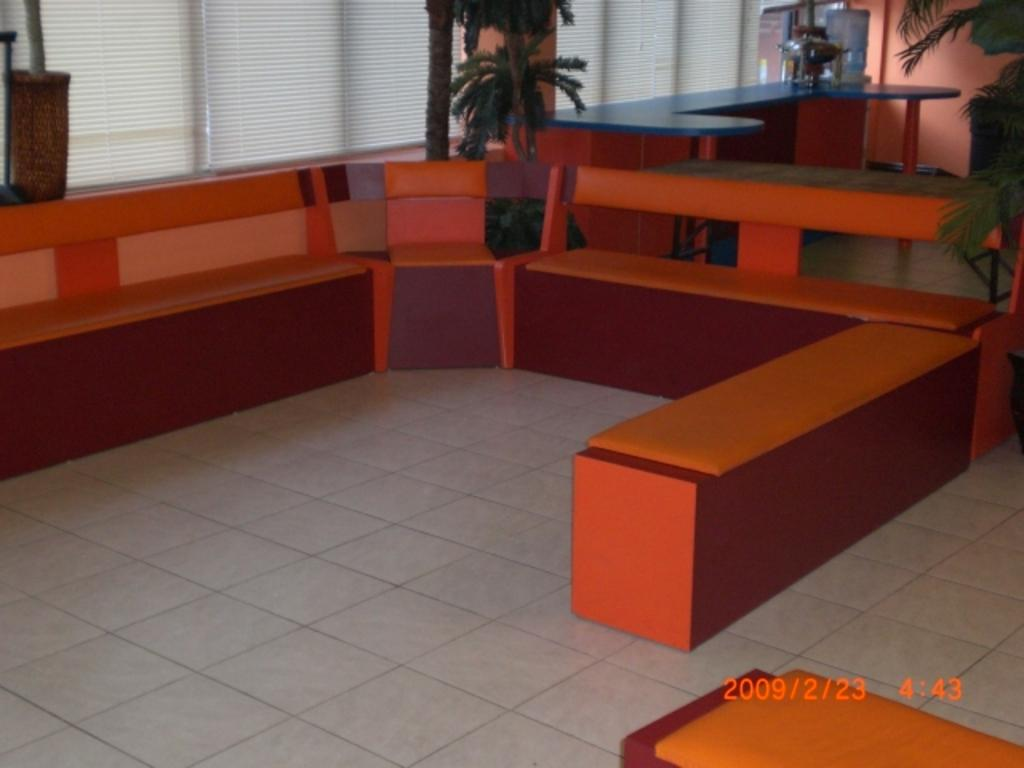What type of furniture is located at the front of the image? There are couches in the front of the image. What can be seen in the background of the image? There is a window with blinds, plants, a wall, and a water tin in the background of the image. Are there any numbers visible in the image? Yes, there are numbers visible at the right bottom of the image. What type of prose is being recited by the authority figure in the image? There is no authority figure or prose present in the image. What type of industry is depicted in the image? There is no industry depicted in the image; it features couches, a window, plants, a wall, a water tin, and numbers. 